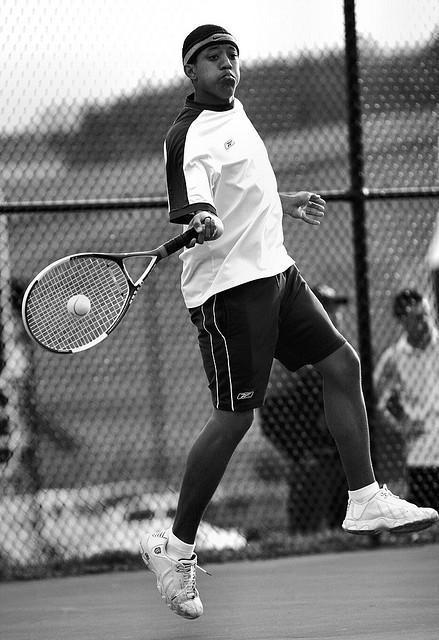How many tennis balls are in this photo?
Give a very brief answer. 1. How many people are in the photo?
Give a very brief answer. 3. 